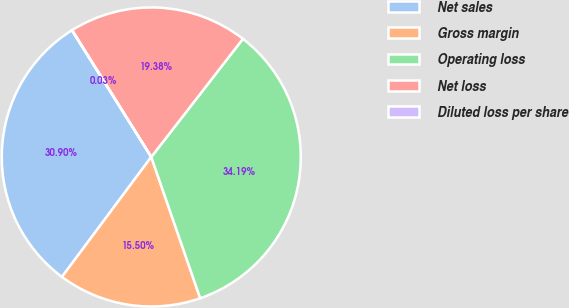Convert chart. <chart><loc_0><loc_0><loc_500><loc_500><pie_chart><fcel>Net sales<fcel>Gross margin<fcel>Operating loss<fcel>Net loss<fcel>Diluted loss per share<nl><fcel>30.9%<fcel>15.5%<fcel>34.19%<fcel>19.38%<fcel>0.03%<nl></chart> 